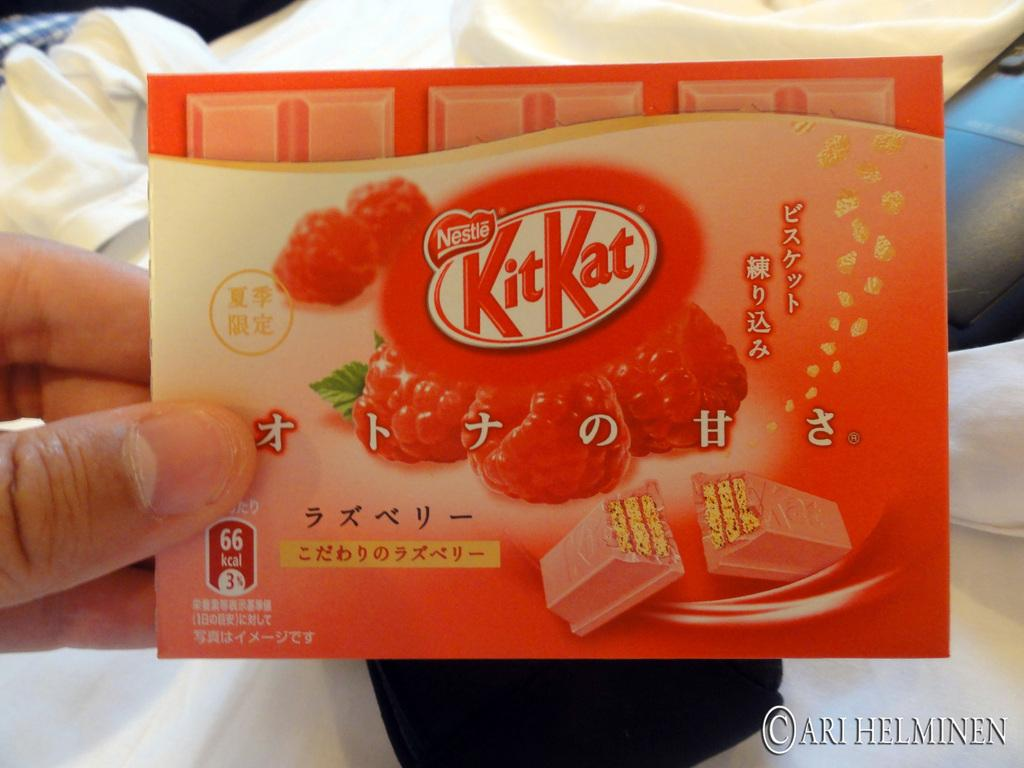Who or what is present in the image? There is a person in the image. What is the person holding in their hands? The person is holding a chocolate wrapper in their hands. What can be seen in the background of the image? There are clothes visible in the background of the image. What type of reaction does the deer have when it sees the person in the image? There is no deer present in the image, so it is not possible to determine its reaction. 